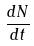<formula> <loc_0><loc_0><loc_500><loc_500>\frac { d N } { d t }</formula> 